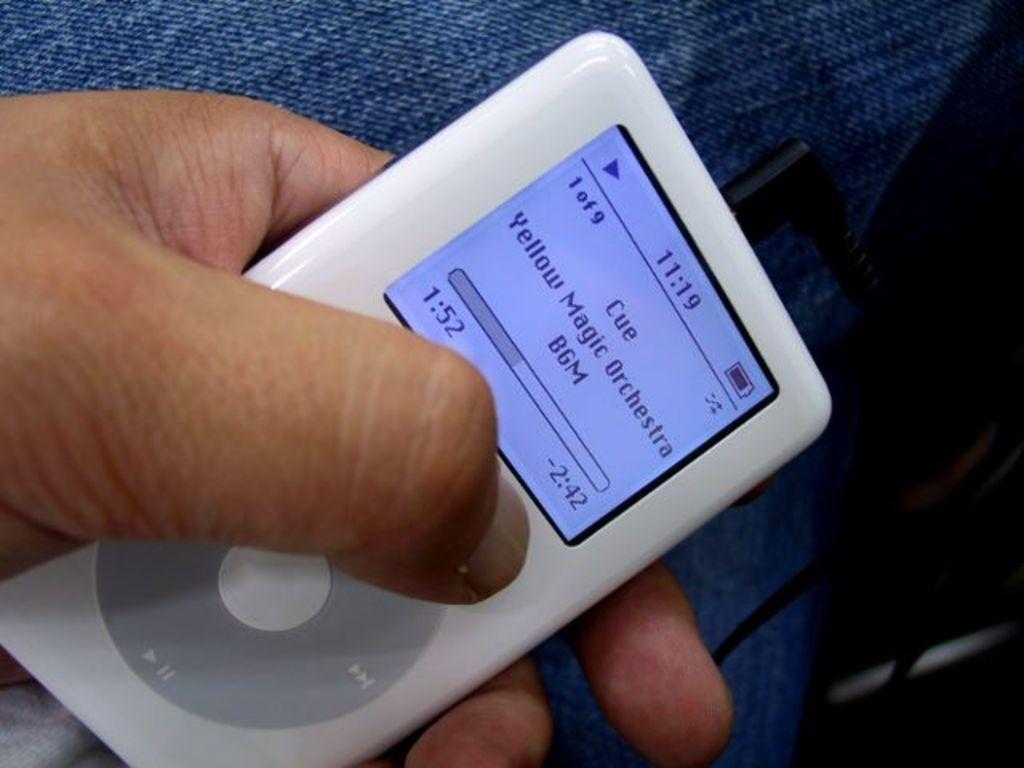Describe this image in one or two sentences. This is ipod in the hand. 